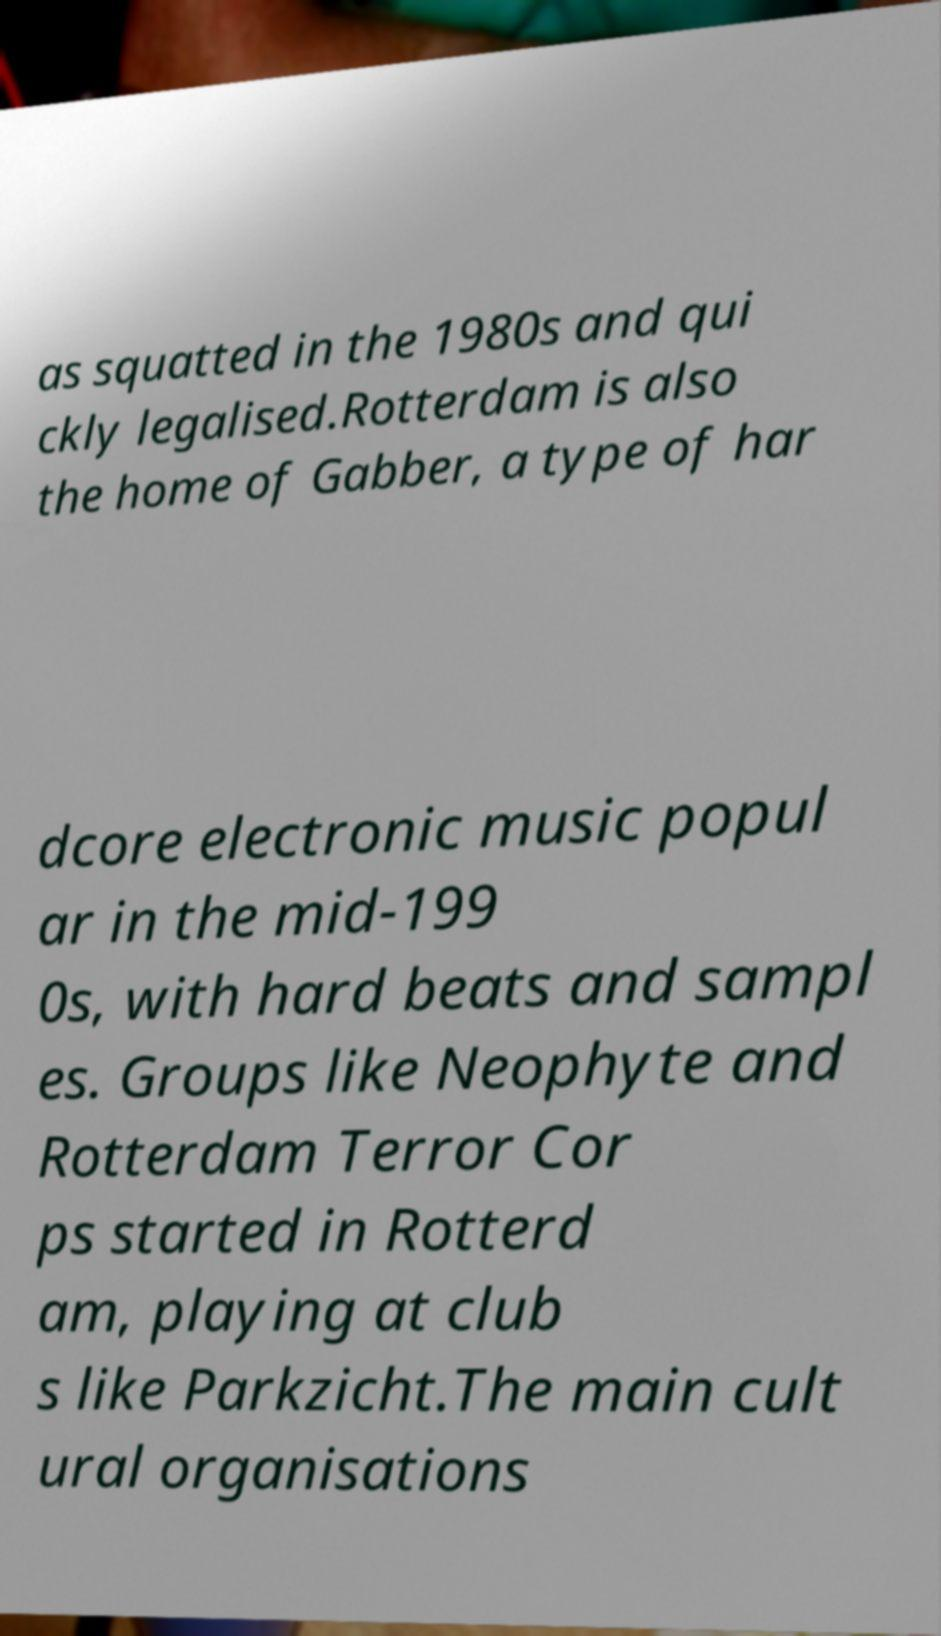Can you read and provide the text displayed in the image?This photo seems to have some interesting text. Can you extract and type it out for me? as squatted in the 1980s and qui ckly legalised.Rotterdam is also the home of Gabber, a type of har dcore electronic music popul ar in the mid-199 0s, with hard beats and sampl es. Groups like Neophyte and Rotterdam Terror Cor ps started in Rotterd am, playing at club s like Parkzicht.The main cult ural organisations 